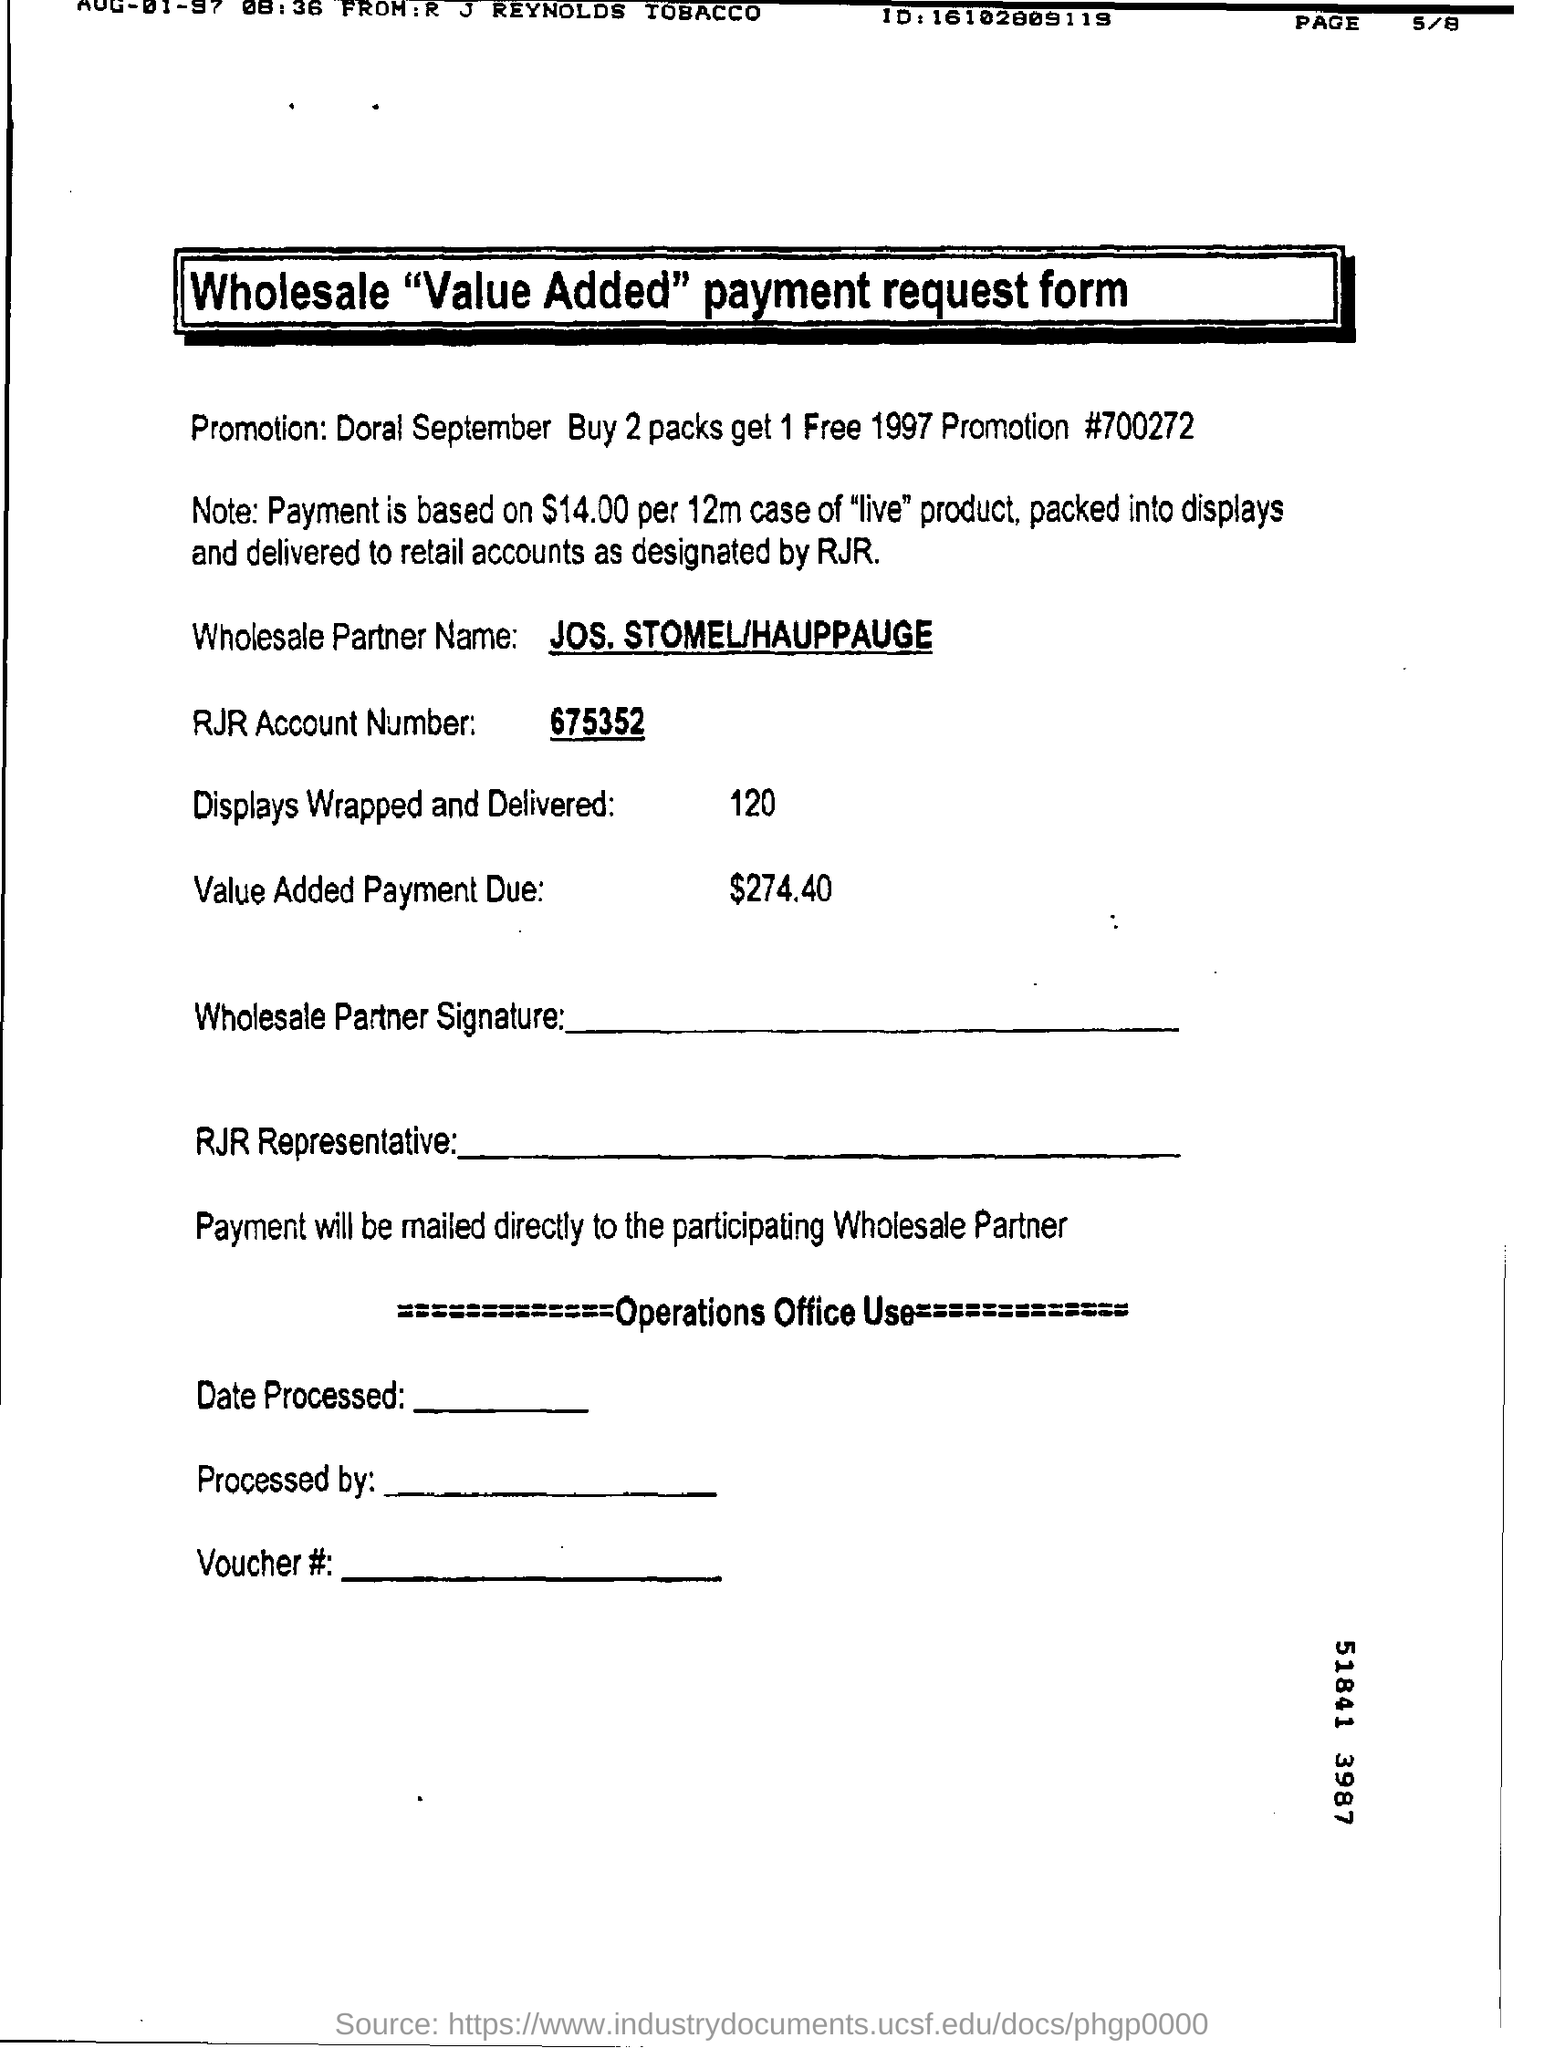Identify some key points in this picture. What is a value added payment due? The amount is 274.40... I wrapped and delivered 120 displays. The name of the wholesale partner is Jos. Stomel/Hauppauge. What form is this, as per the title, wholesale 'value added' payment request form. The RJR account number is 675352. 